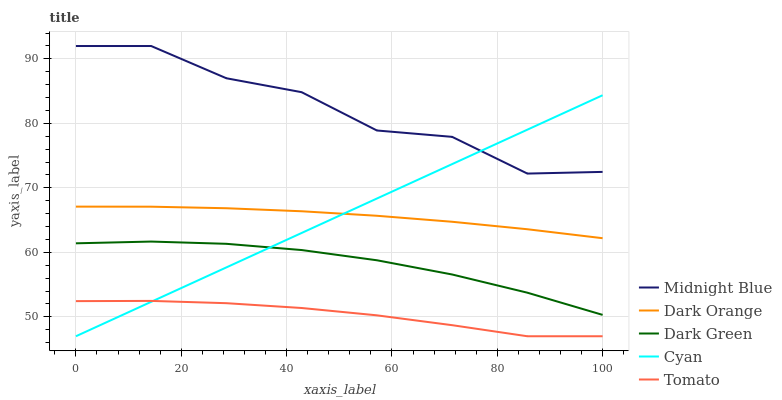Does Tomato have the minimum area under the curve?
Answer yes or no. Yes. Does Midnight Blue have the maximum area under the curve?
Answer yes or no. Yes. Does Dark Orange have the minimum area under the curve?
Answer yes or no. No. Does Dark Orange have the maximum area under the curve?
Answer yes or no. No. Is Cyan the smoothest?
Answer yes or no. Yes. Is Midnight Blue the roughest?
Answer yes or no. Yes. Is Dark Orange the smoothest?
Answer yes or no. No. Is Dark Orange the roughest?
Answer yes or no. No. Does Tomato have the lowest value?
Answer yes or no. Yes. Does Dark Orange have the lowest value?
Answer yes or no. No. Does Midnight Blue have the highest value?
Answer yes or no. Yes. Does Dark Orange have the highest value?
Answer yes or no. No. Is Tomato less than Midnight Blue?
Answer yes or no. Yes. Is Midnight Blue greater than Dark Green?
Answer yes or no. Yes. Does Tomato intersect Cyan?
Answer yes or no. Yes. Is Tomato less than Cyan?
Answer yes or no. No. Is Tomato greater than Cyan?
Answer yes or no. No. Does Tomato intersect Midnight Blue?
Answer yes or no. No. 